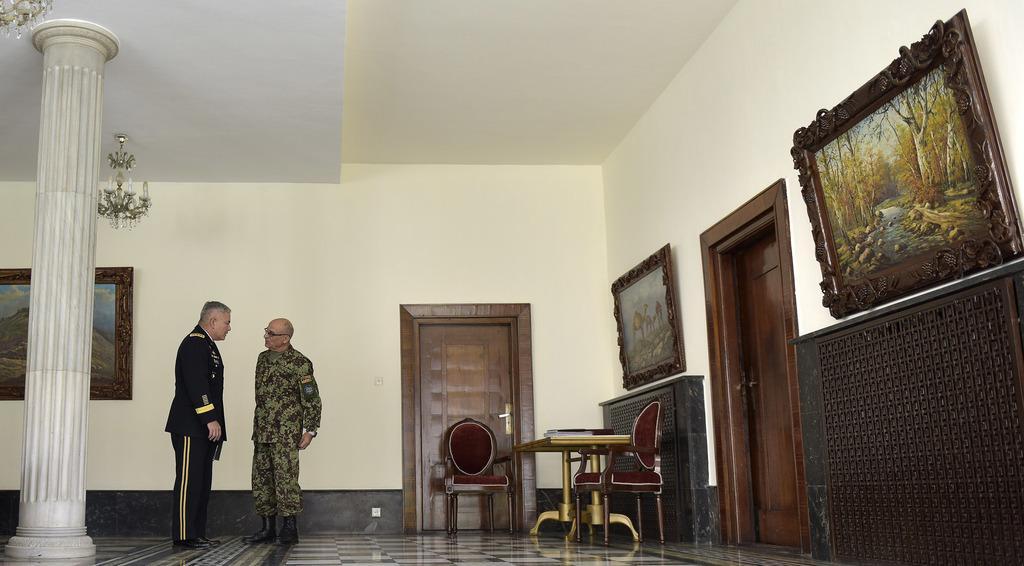What are the two persons in the image doing? The two persons in the image are talking to each other. Where are the persons located in the image? The persons are on the left side of the image. What can be seen on the wall in the image? There are frames on the wall. What type of furniture is present in the image? Chairs and tables are visible in the image. What architectural feature is present in the image? Doors are in the image. What is hanging from the roof in the image? A chandelier is hanging from the roof. Can you see any veins in the image? There are no visible veins in the image; it features two persons talking and various elements of a room. What book is the person reading in the image? There is no book present in the image; it only shows two persons talking and the surrounding environment. 